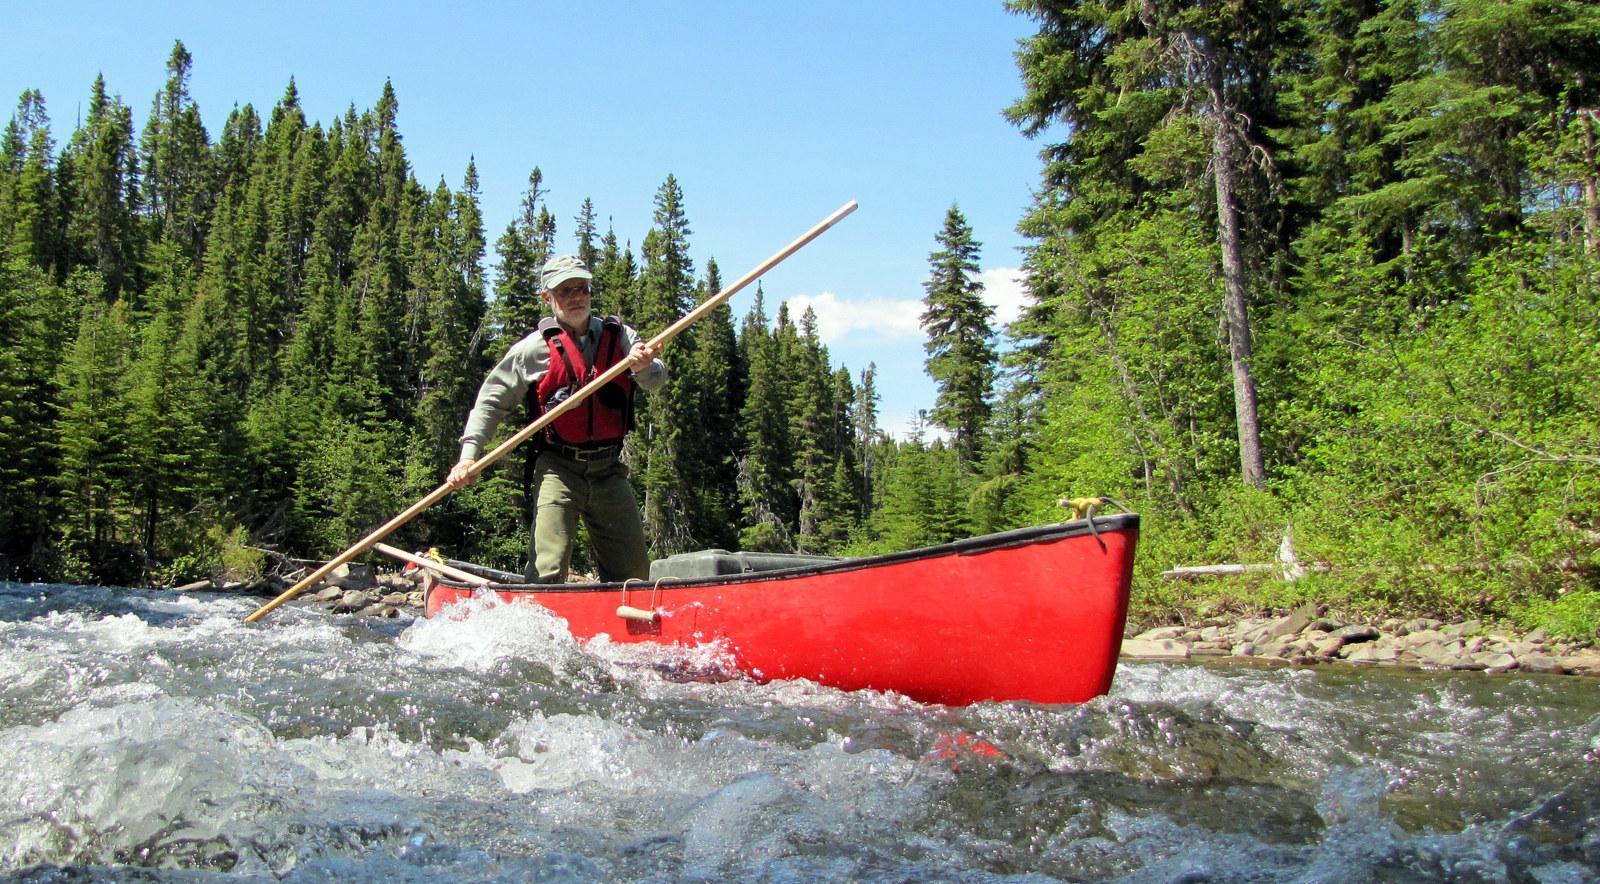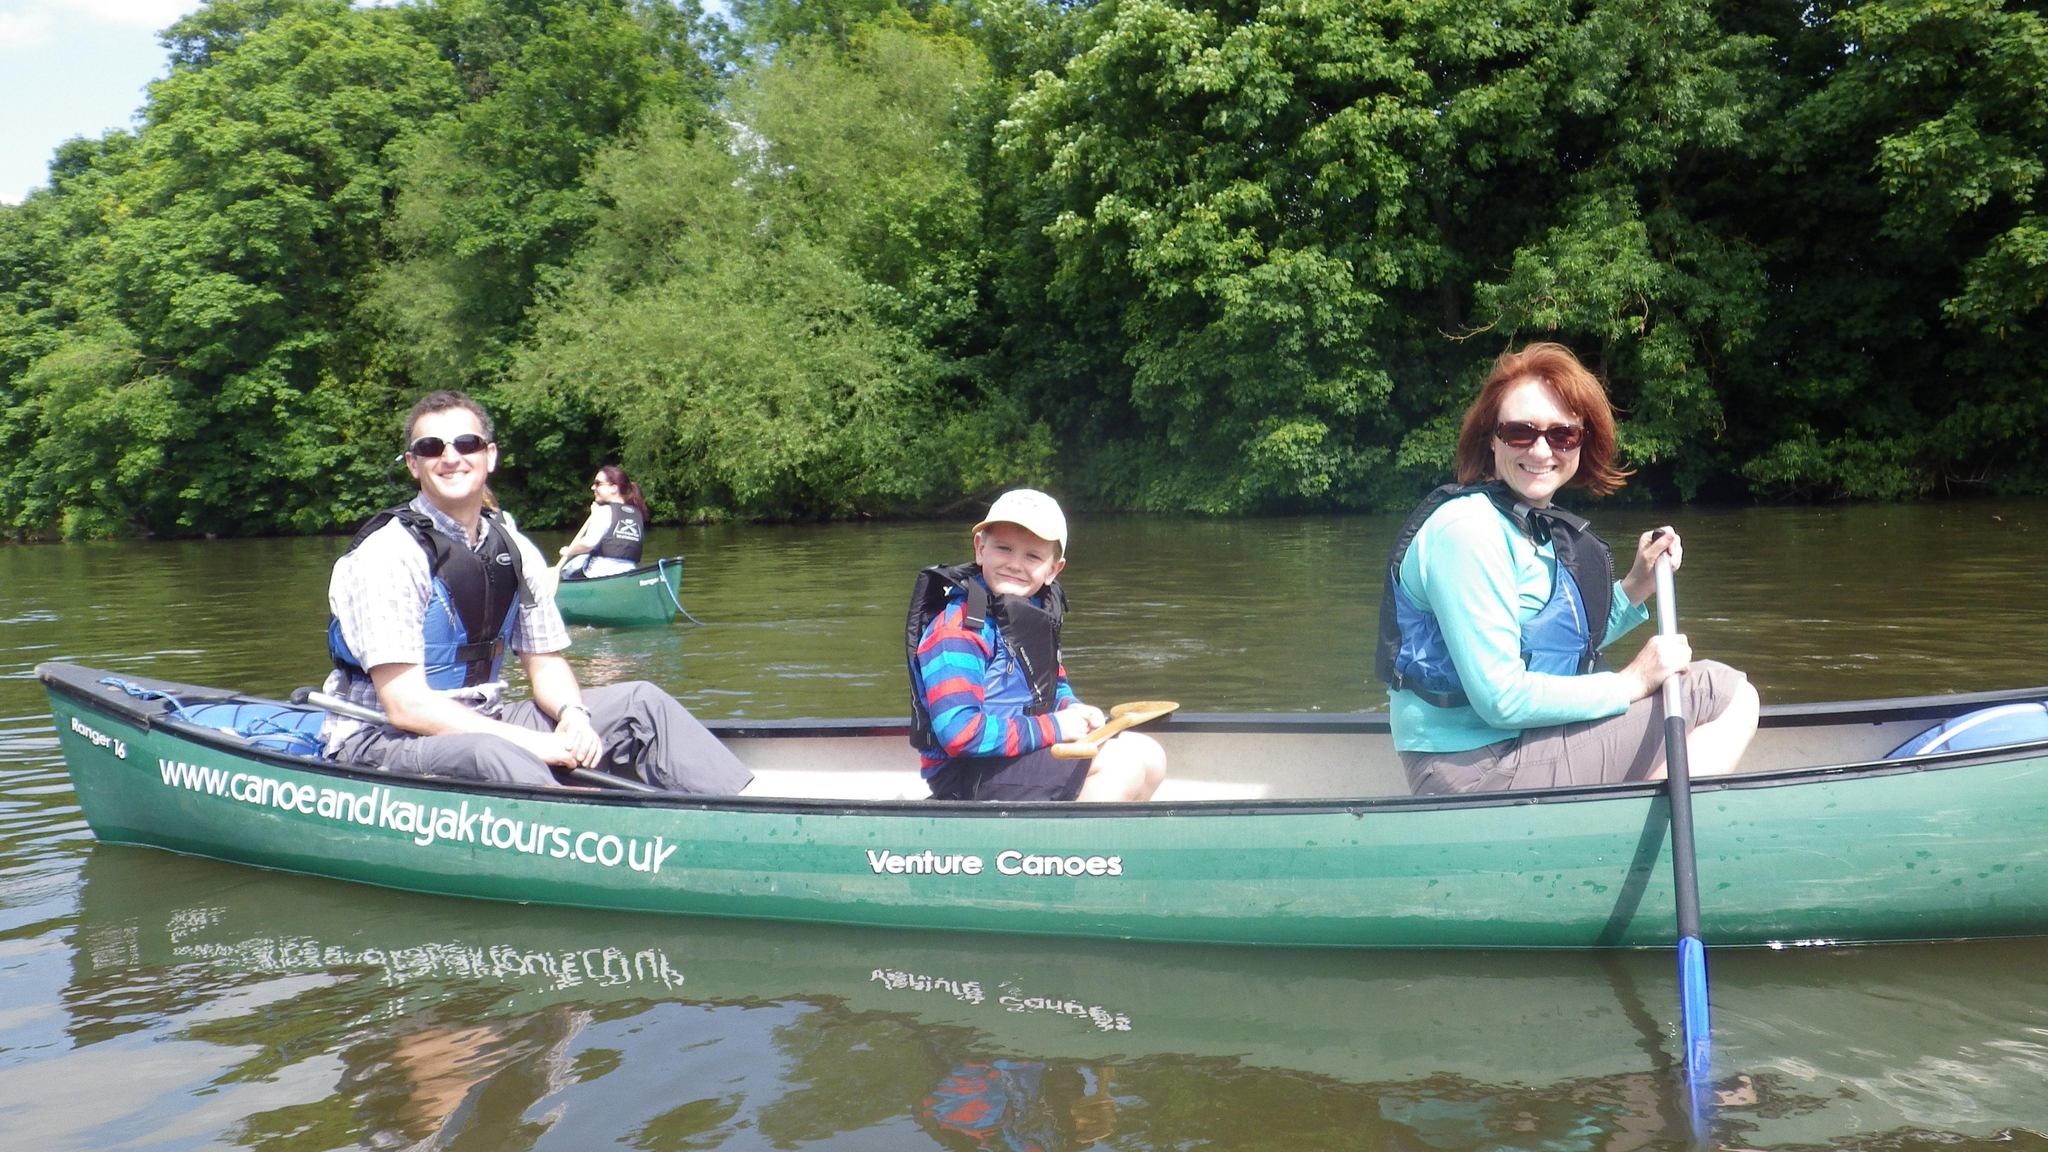The first image is the image on the left, the second image is the image on the right. For the images displayed, is the sentence "There are exactly two canoes in the water." factually correct? Answer yes or no. Yes. 